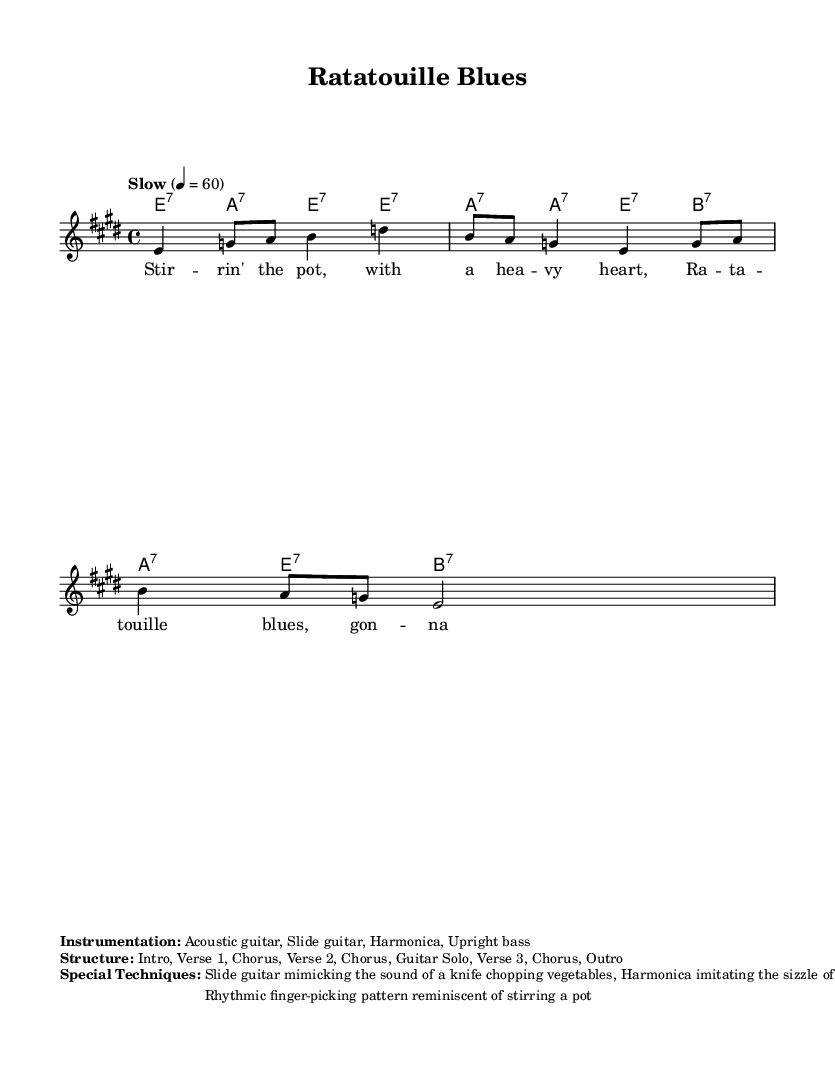What is the key signature of this music? The key signature is E major, which has four sharps (F#, C#, G#, D#). This is determined by looking at the key signature line at the beginning of the sheet music.
Answer: E major What is the time signature of the piece? The time signature is 4/4, which means there are four beats in each measure and a quarter note gets one beat. This can be found next to the clef at the beginning of the staff.
Answer: 4/4 What is the tempo marking of this piece? The tempo marking is "Slow" at the beginning of the sheet music, indicating the speed at which the music should be played. The exact metronome value is also provided as 4 = 60, where the quarter note gets sixty beats per minute.
Answer: Slow What instruments are featured in this composition? The featured instruments as listed in the markup section are Acoustic guitar, Slide guitar, Harmonica, and Upright bass. This information specifies what musicians are needed to perform the piece.
Answer: Acoustic guitar, Slide guitar, Harmonica, Upright bass What is the structure of this piece? The structure outlined in the markup section indicates the order of the musical sections, which includes Intro, Verse 1, Chorus, Verse 2, Chorus, Guitar Solo, Verse 3, Chorus, and Outro. This gives a clear view of how the composition is organized.
Answer: Intro, Verse 1, Chorus, Verse 2, Chorus, Guitar Solo, Verse 3, Chorus, Outro What are the special techniques used in this piece? The special techniques mentioned include Slide guitar mimicking the sound of a knife chopping vegetables, Harmonica imitating the sizzle of a hot pan, and a rhythmic finger-picking pattern reminiscent of stirring a pot. This highlights the unique and thematic elements of the music.
Answer: Slide guitar, Harmonica, Finger-picking 